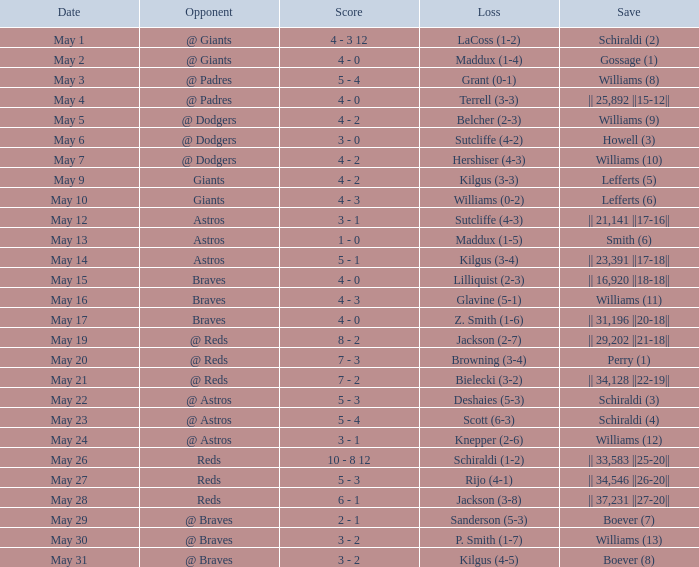Name the opponent for save of williams (9) @ Dodgers. 